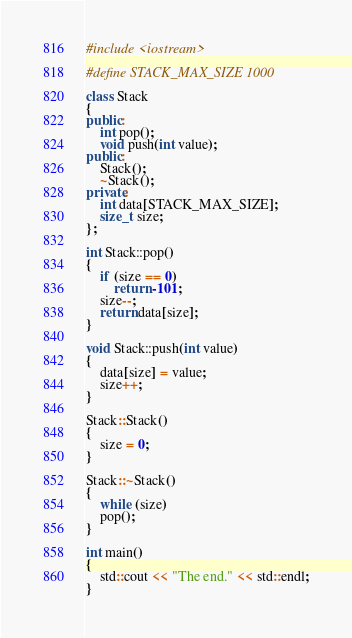<code> <loc_0><loc_0><loc_500><loc_500><_C++_>#include <iostream>

#define STACK_MAX_SIZE 1000

class Stack
{
public:
    int pop();
    void push(int value);
public:
    Stack();
    ~Stack();
private:
    int data[STACK_MAX_SIZE];
    size_t size;
};

int Stack::pop()
{
    if (size == 0)
        return -101;
    size--;
    return data[size];
}

void Stack::push(int value)
{
    data[size] = value;
    size++;
}

Stack::Stack()
{
    size = 0;
}

Stack::~Stack()
{
    while (size)
    pop();
}

int main()
{
    std::cout << "The end." << std::endl;
}
</code> 